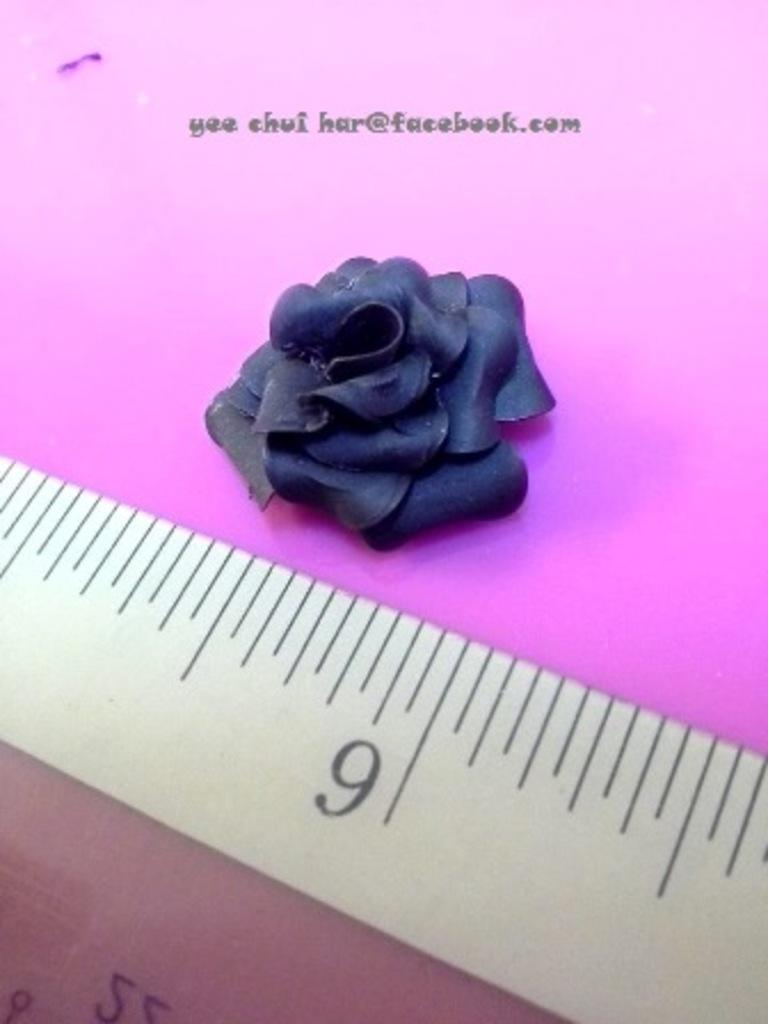<image>
Provide a brief description of the given image. A blue flower is displayed next to an email with a facebook.com address. 